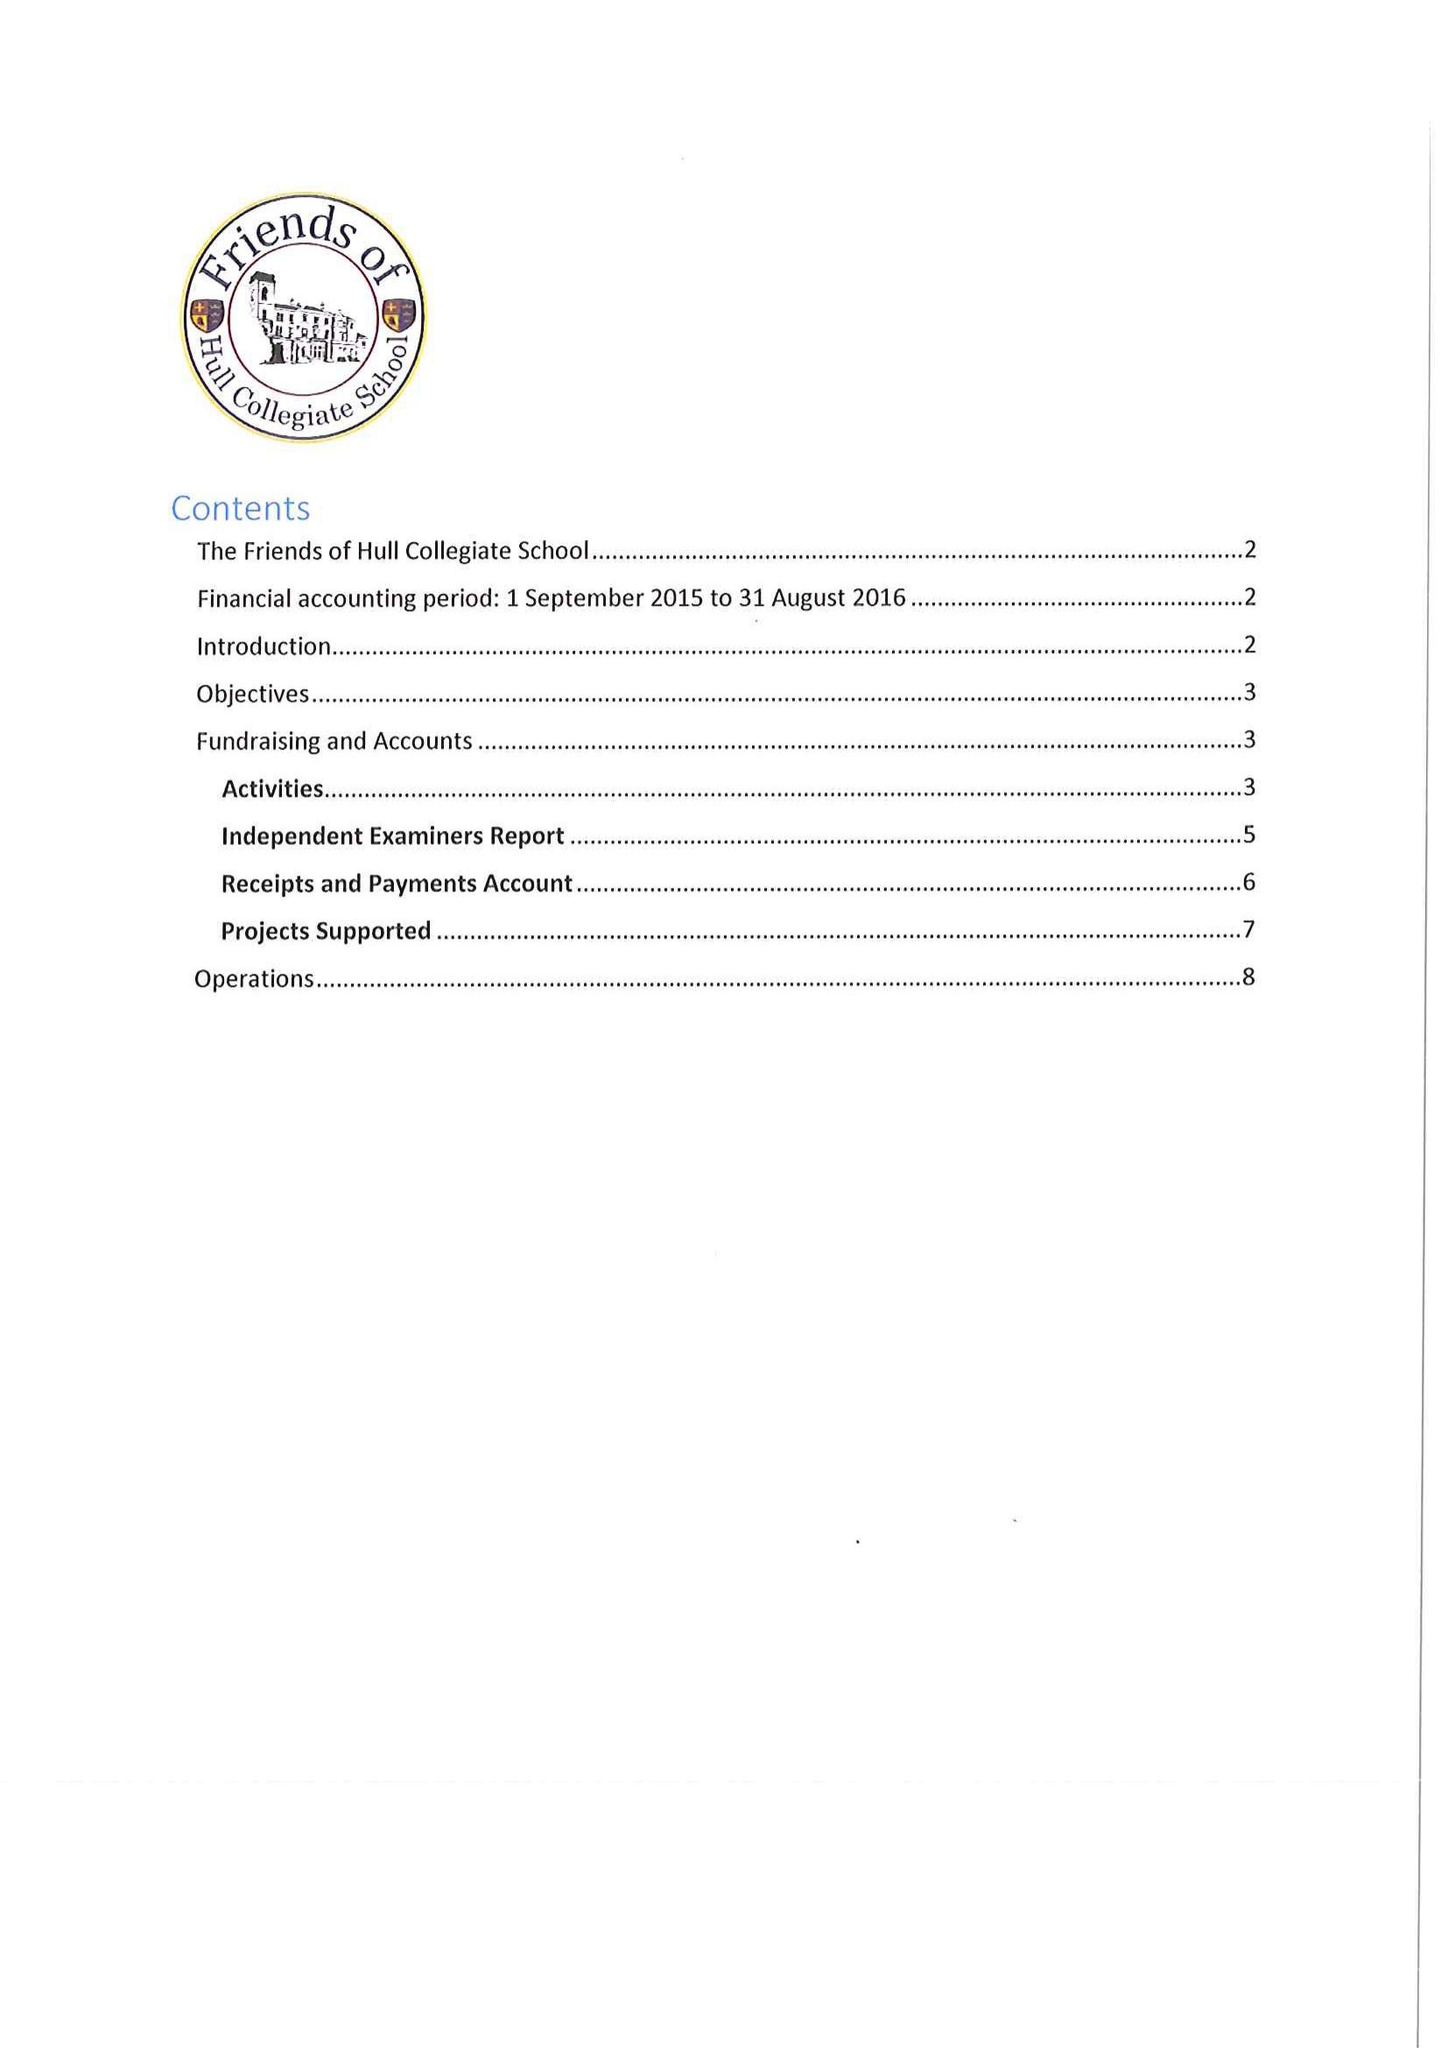What is the value for the address__postcode?
Answer the question using a single word or phrase. HU10 7EH 